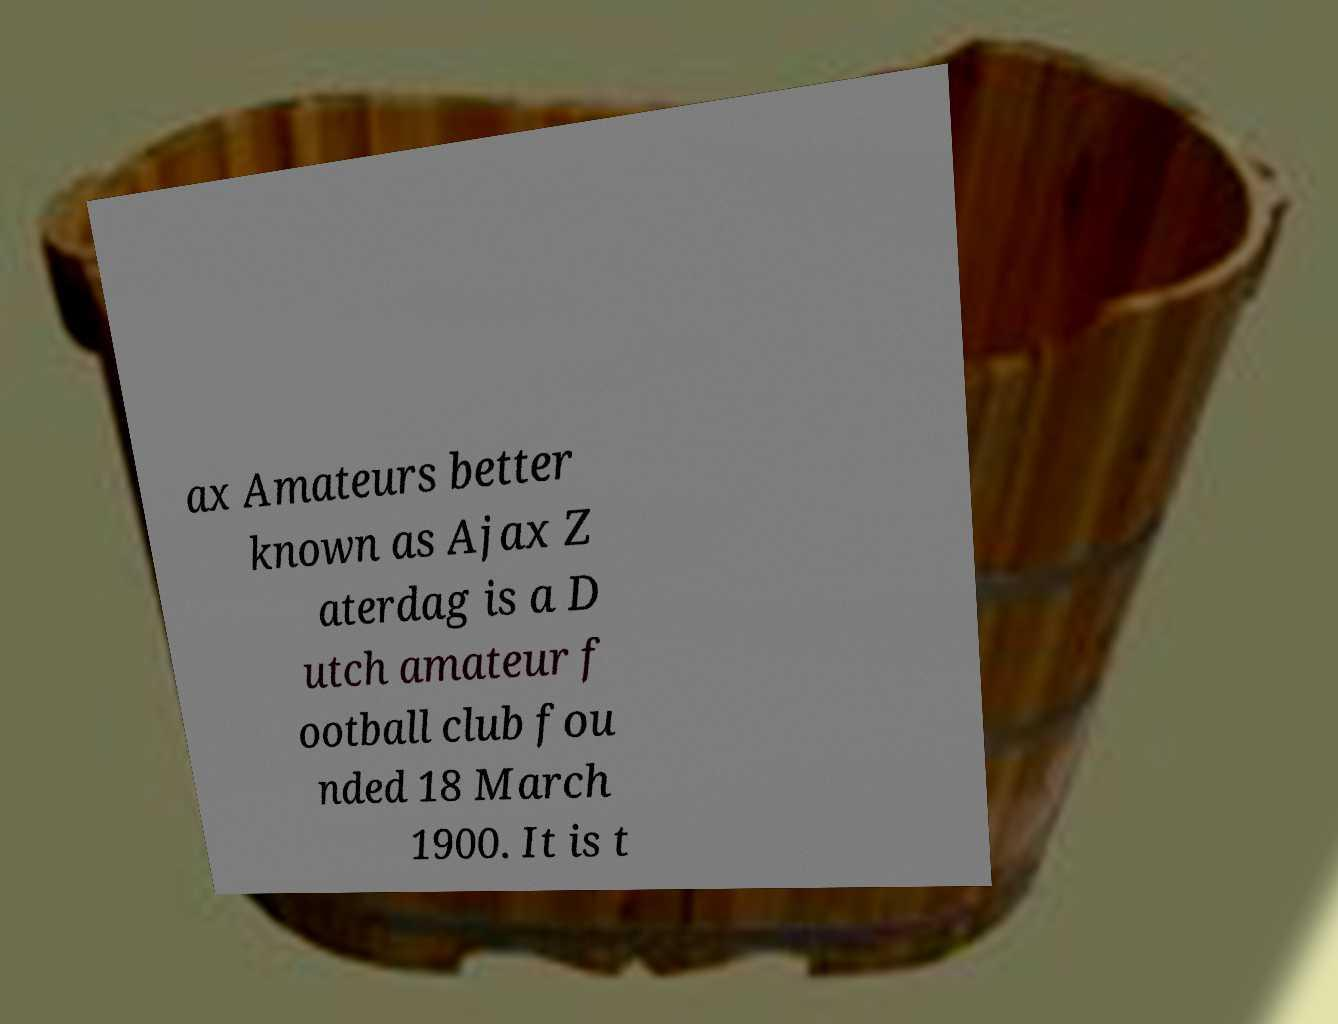Please read and relay the text visible in this image. What does it say? ax Amateurs better known as Ajax Z aterdag is a D utch amateur f ootball club fou nded 18 March 1900. It is t 